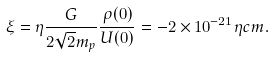Convert formula to latex. <formula><loc_0><loc_0><loc_500><loc_500>\xi = \eta \frac { G } { 2 \sqrt { 2 } m _ { p } } \frac { \rho ( { 0 } ) } { U ( { 0 } ) } = - 2 \times 1 0 ^ { - 2 1 } \eta c m .</formula> 